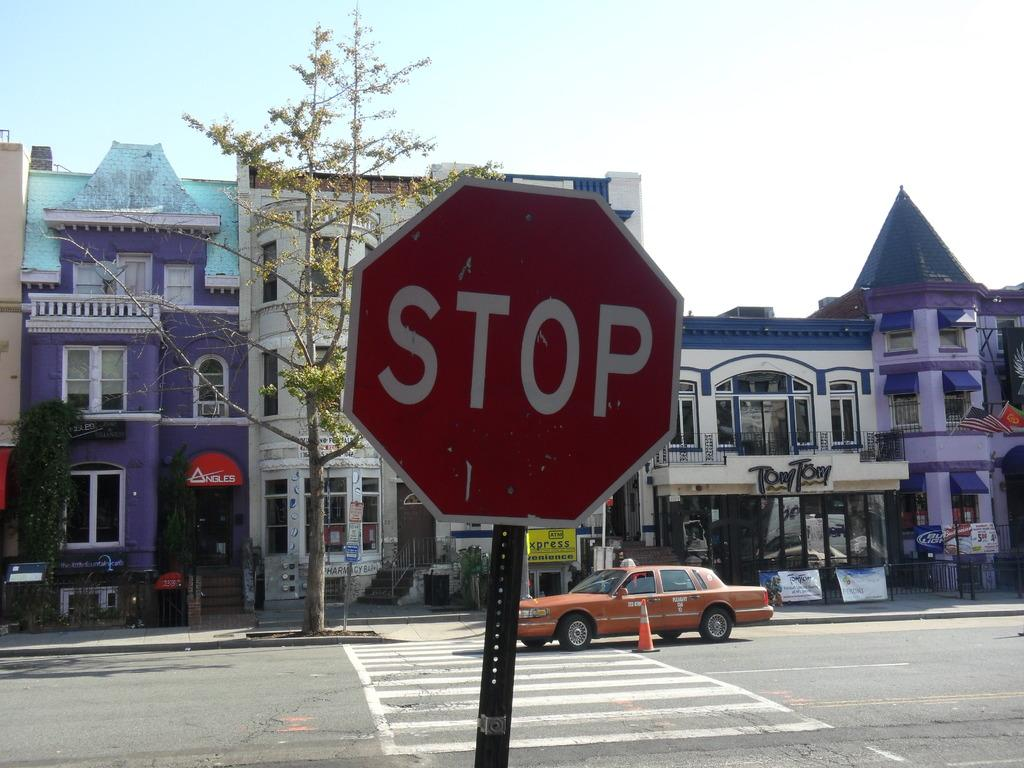<image>
Offer a succinct explanation of the picture presented. A red sign that says Stop is by an intersection with an orange car in it. 